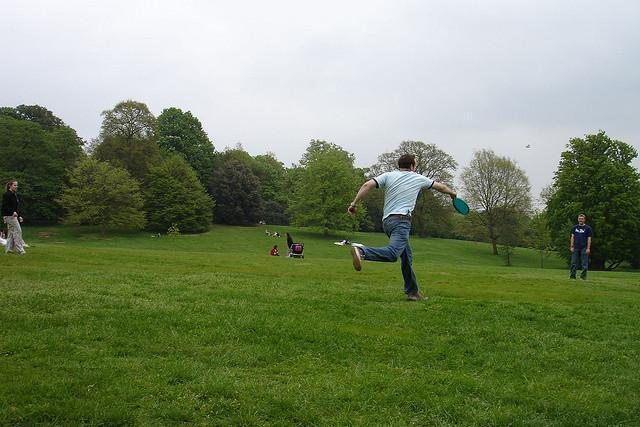How many street lights are in the picture?
Give a very brief answer. 0. 